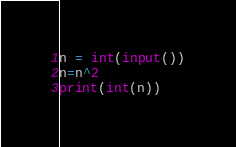Convert code to text. <code><loc_0><loc_0><loc_500><loc_500><_Python_>n = int(input())
n=n^2
print(int(n))</code> 